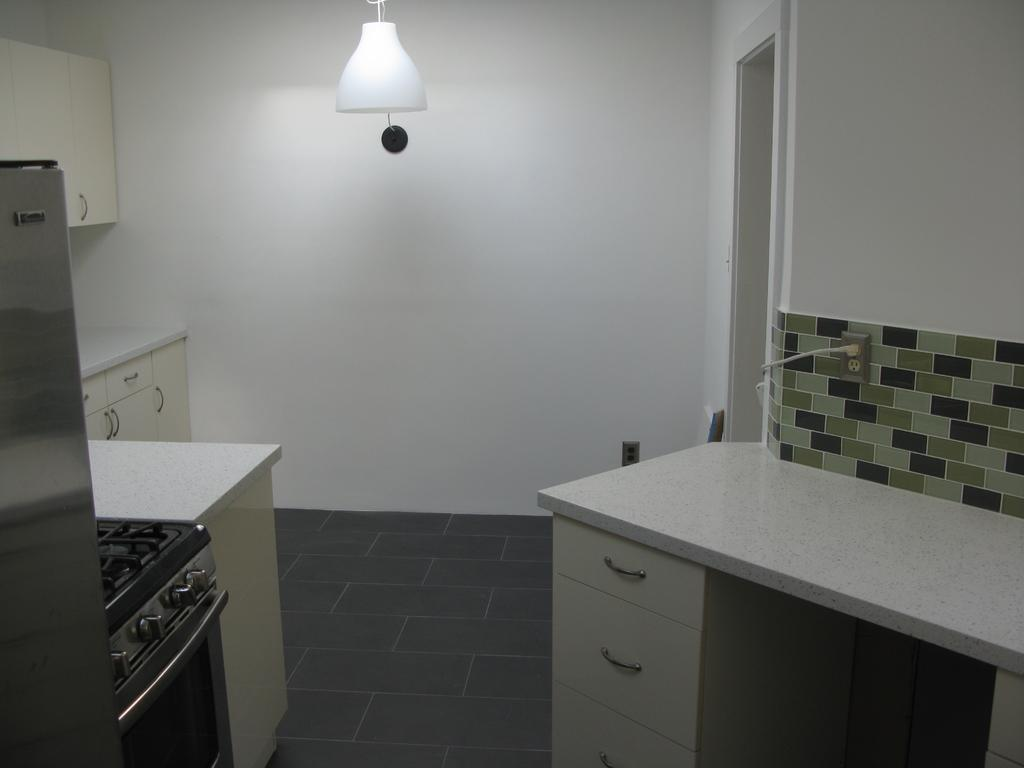What type of space is shown in the image? The image depicts an inside view of a room. What type of furniture or appliances can be seen in the room? There are cupboards, an oven, a gas stove, and a refrigerator in the room. Is there a source of light in the room? Yes, there is a light in the room. What type of prose can be seen written on the cupboards in the image? There is no prose visible on the cupboards in the image; they are simply cupboards without any writing or text. 